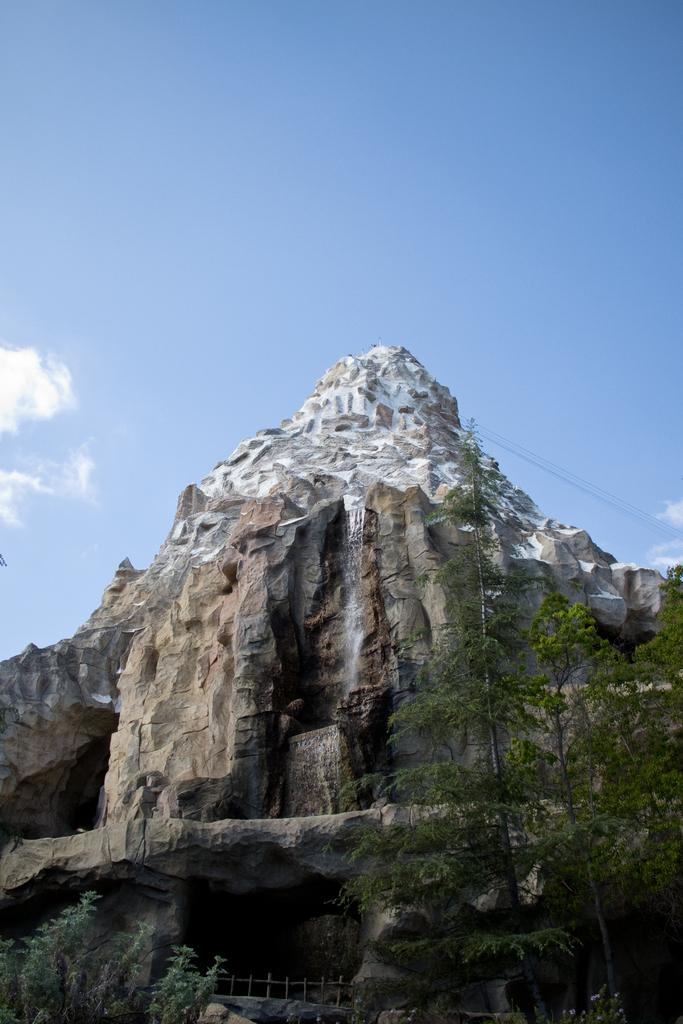What is the main geographical feature in the picture? There is a mountain in the picture. What type of vegetation can be seen in the picture? There are trees in the picture. What is visible in the background of the picture? The sky is clear and visible in the background of the picture. What color is the shirt worn by the tree in the picture? There are no shirts or people present in the image, as it features a mountain and trees. 